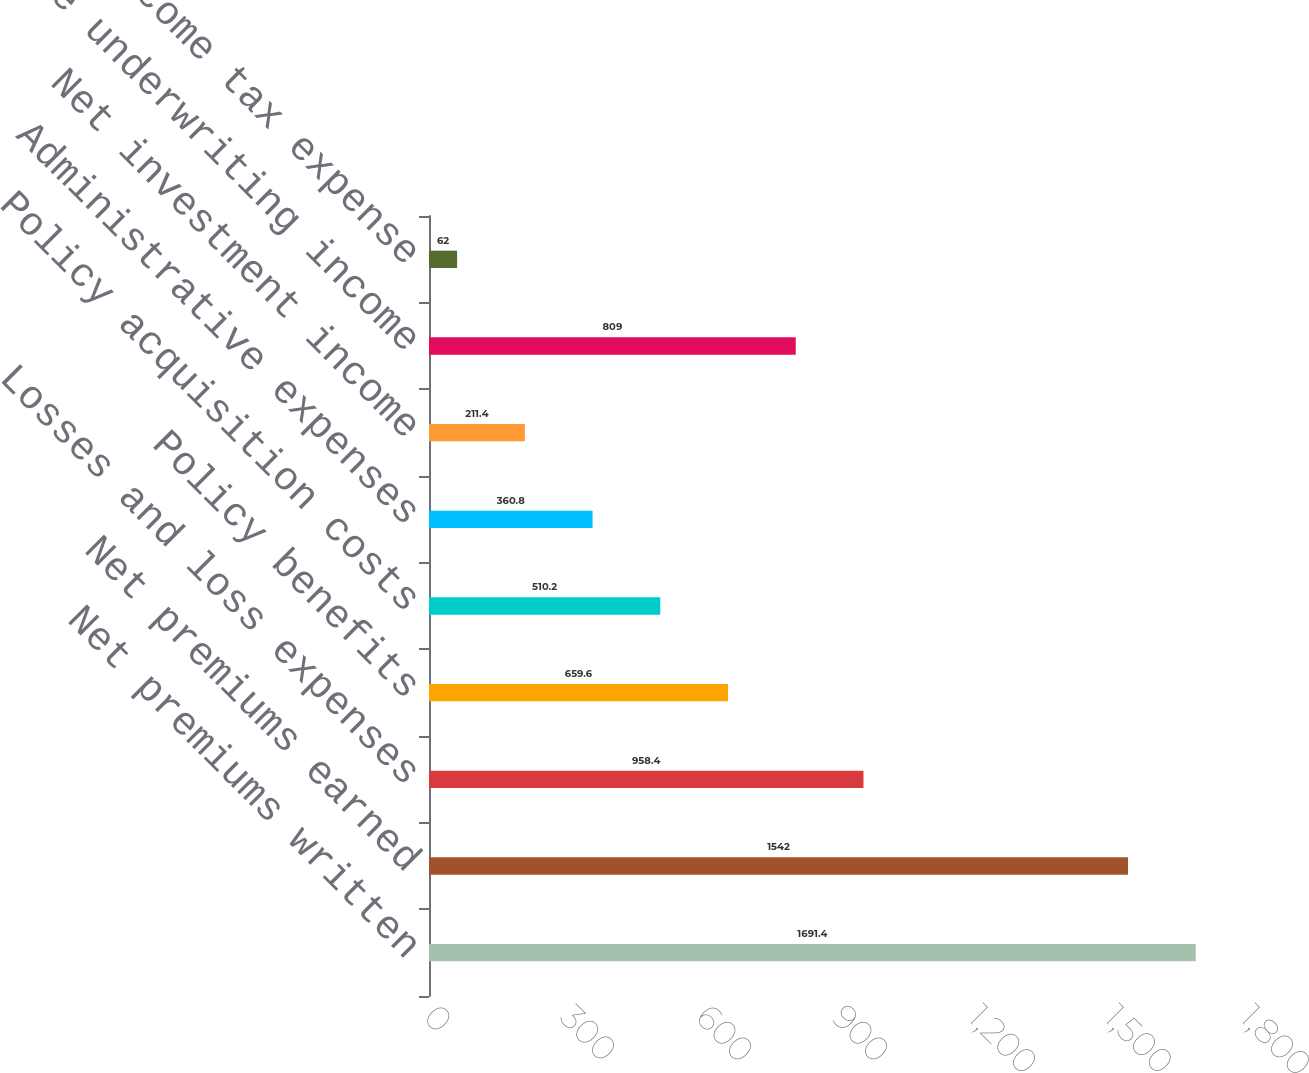Convert chart. <chart><loc_0><loc_0><loc_500><loc_500><bar_chart><fcel>Net premiums written<fcel>Net premiums earned<fcel>Losses and loss expenses<fcel>Policy benefits<fcel>Policy acquisition costs<fcel>Administrative expenses<fcel>Net investment income<fcel>Life underwriting income<fcel>Income tax expense<nl><fcel>1691.4<fcel>1542<fcel>958.4<fcel>659.6<fcel>510.2<fcel>360.8<fcel>211.4<fcel>809<fcel>62<nl></chart> 